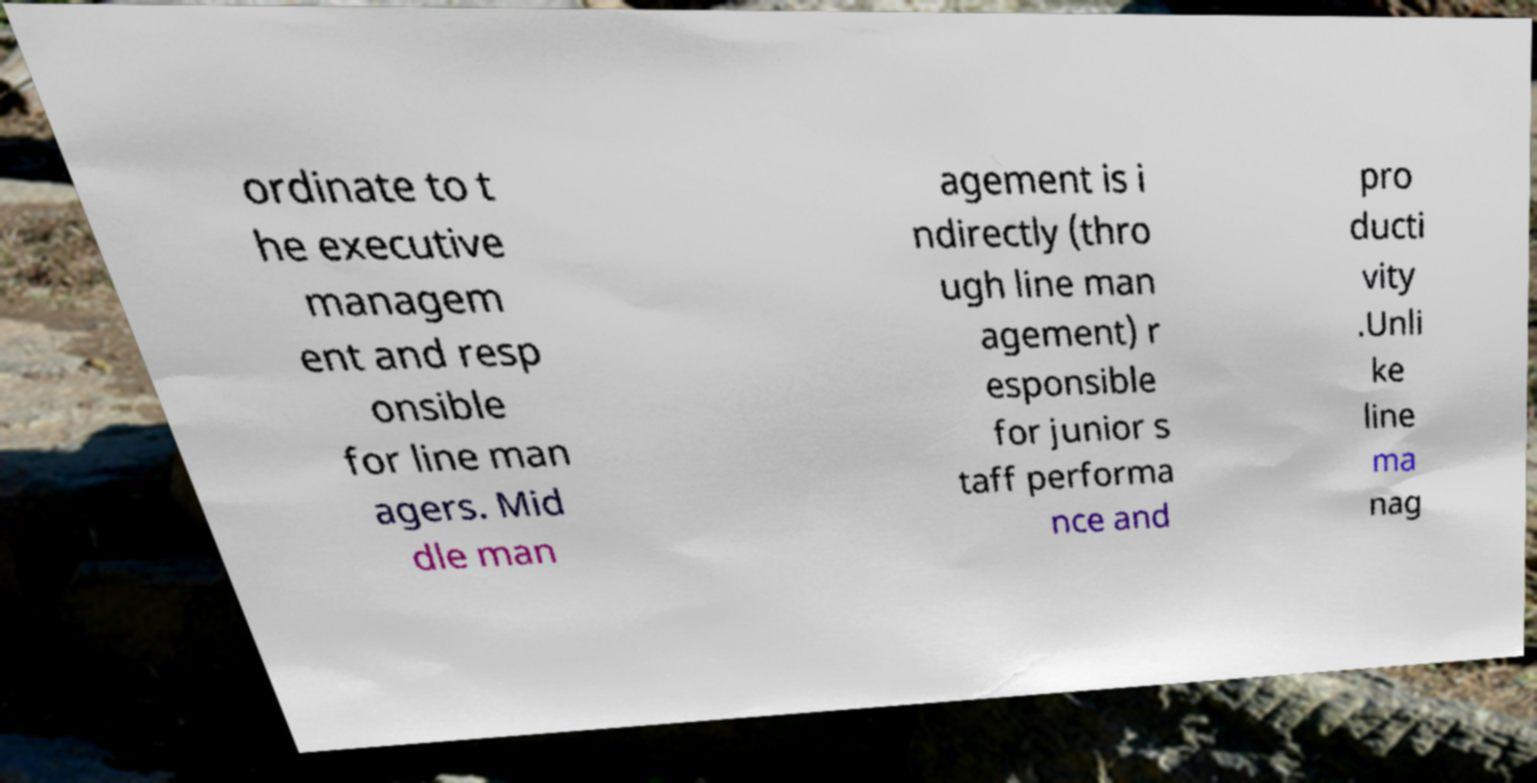Please read and relay the text visible in this image. What does it say? ordinate to t he executive managem ent and resp onsible for line man agers. Mid dle man agement is i ndirectly (thro ugh line man agement) r esponsible for junior s taff performa nce and pro ducti vity .Unli ke line ma nag 